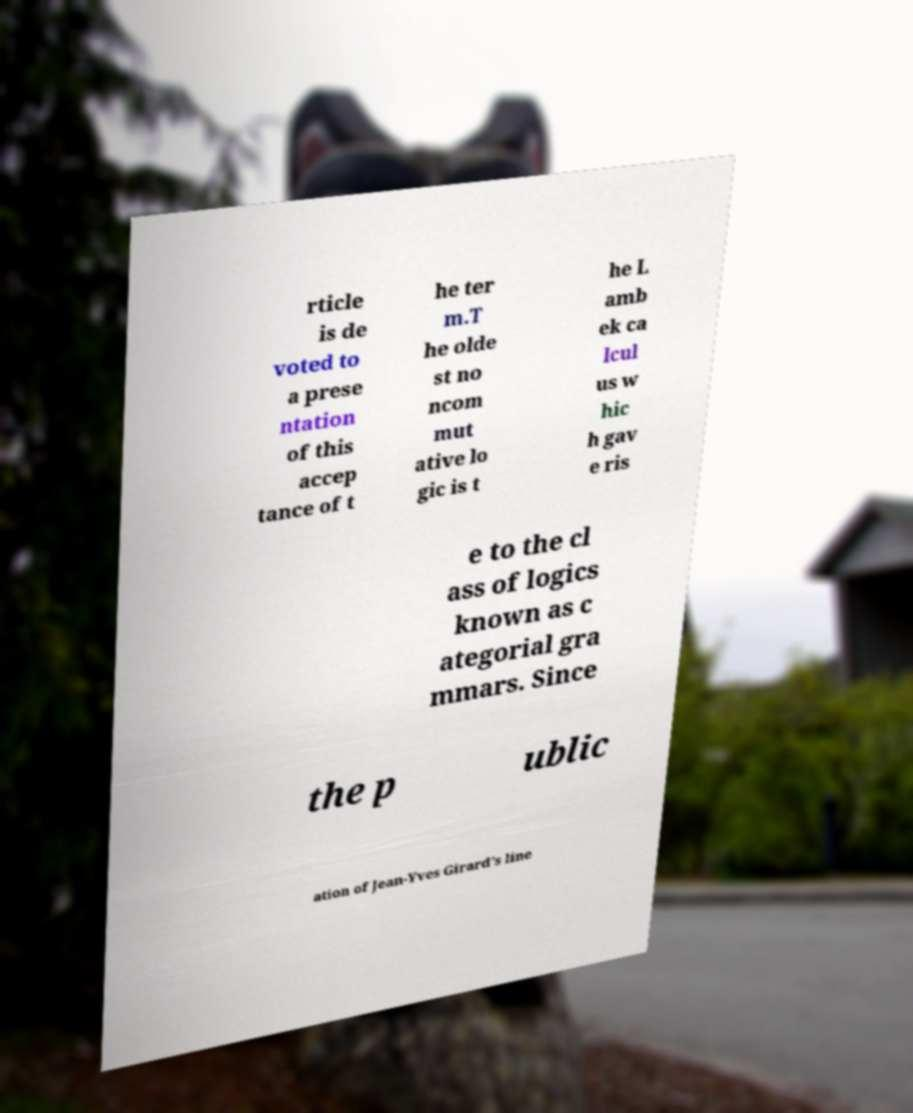Please identify and transcribe the text found in this image. rticle is de voted to a prese ntation of this accep tance of t he ter m.T he olde st no ncom mut ative lo gic is t he L amb ek ca lcul us w hic h gav e ris e to the cl ass of logics known as c ategorial gra mmars. Since the p ublic ation of Jean-Yves Girard's line 